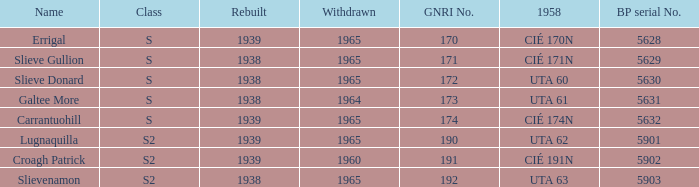What is the smallest withdrawn value with a GNRI greater than 172, name of Croagh Patrick and was rebuilt before 1939? None. 